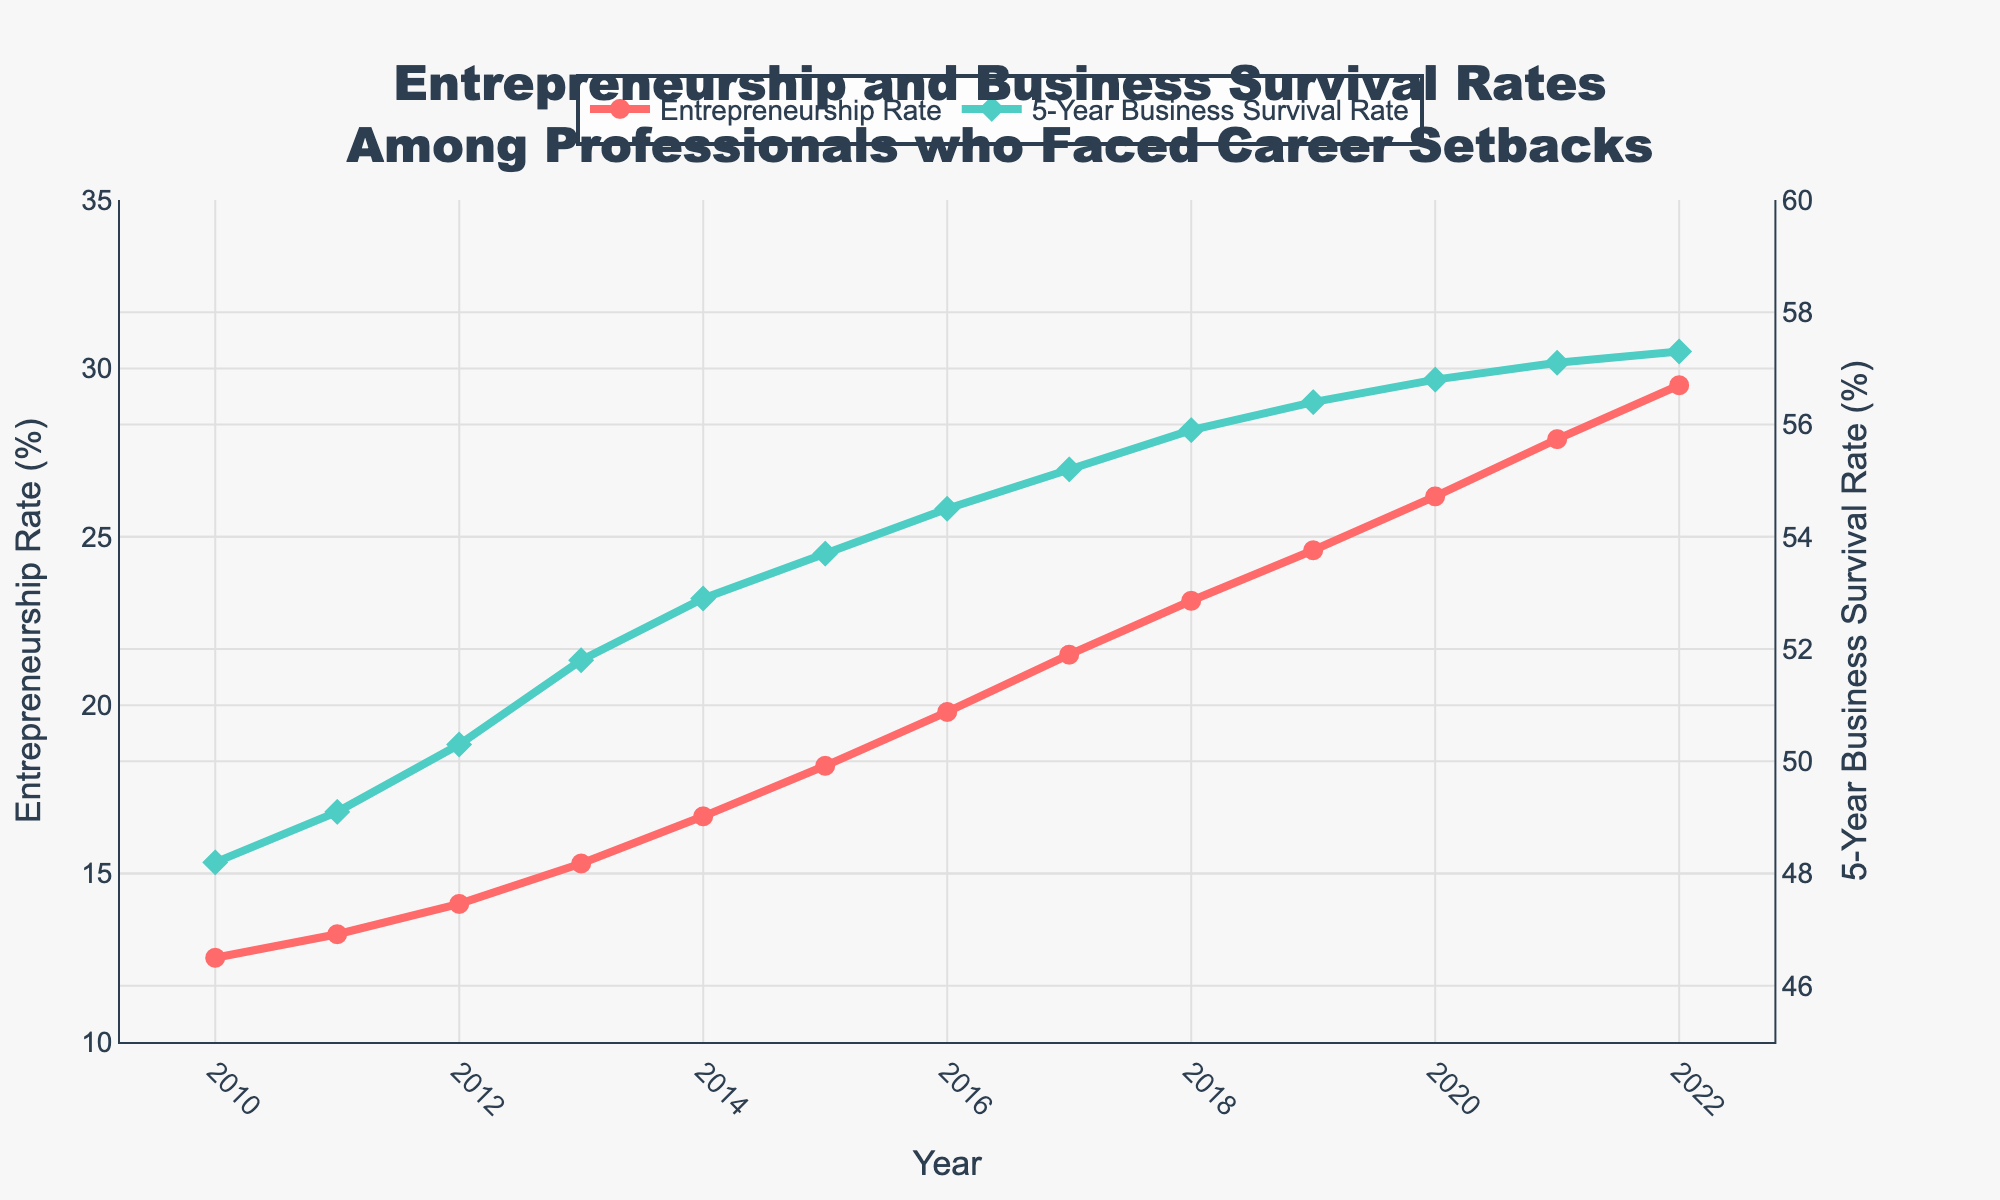What was the Entrepreneurship Rate in 2015? To find the Entrepreneurship Rate in 2015, locate the year 2015 on the x-axis and read the value on the left y-axis where it intersects the line representing the Entrepreneurship Rate. It is 18.2%.
Answer: 18.2% How do the Entrepreneurship Rate and 5-Year Business Survival Rate compare in 2018? To compare the two rates in 2018, locate the year 2018 on the x-axis. Check the Entrepreneurship Rate on the left y-axis, which is 23.1%, and the 5-Year Business Survival Rate on the right y-axis, which is 55.9%.
Answer: Entrepreneurship Rate: 23.1%, Business Survival Rate: 55.9% What is the average Entrepreneurship Rate over the five-year period from 2015 to 2019? The average is calculated by summing the Entrepreneurship Rates from 2015 to 2019 and then dividing by the number of years. The values are 18.2% (2015), 19.8% (2016), 21.5% (2017), 23.1% (2018), and 24.6% (2019). Sum: 18.2 + 19.8 + 21.5 + 23.1 + 24.6 = 107.2. Average: 107.2 / 5 = 21.44.
Answer: 21.44% Which year saw the greatest increase in the 5-Year Business Survival Rate compared to the previous year? To find the year with the greatest increase, calculate the annual differences in the 5-Year Business Survival Rate. The largest increase is from 2013 (51.8%) to 2014 (52.9%), which is 52.9 - 51.8 = 1.1%.
Answer: 2014 What is the trend of the Entrepreneurship Rate from 2010 to 2022? Observing the figure, the Entrepreneurship Rate shows a consistent upward trend from 12.5% in 2010 to 29.5% in 2022, indicating an increase over this period.
Answer: Upward trend How many years did it take for the Entrepreneurship Rate to grow from below 20% to above 25%? The rate was below 20% in 2015 (18.2%) and above 25% in 2019 (24.6%). It crossed 25% in 2020 with a rate of 26.2%. Thus, it took 5 years (from 2015 to 2020).
Answer: 5 years In 2022, did the 5-Year Business Survival Rate exceed 57%? In 2022, the 5-Year Business Survival Rate, as indicated on the right y-axis, is 57.3%, which exceeds 57%.
Answer: Yes What is the general relationship between Entrepreneurship Rate and 5-Year Business Survival Rate over the years? Observing the figure, both rates show an upward trend, indicating that as the Entrepreneurship Rate increases, the 5-Year Business Survival Rate also generally improves, although the Survival Rate increases at a slower pace.
Answer: Both increase By how much did the Entrepreneurship Rate increase from 2010 to 2022? To find the increase, subtract the Entrepreneurship Rate of 2010 from that of 2022. The values are 29.5% (2022) and 12.5% (2010), so the increase is 29.5 - 12.5 = 17%.
Answer: 17% 